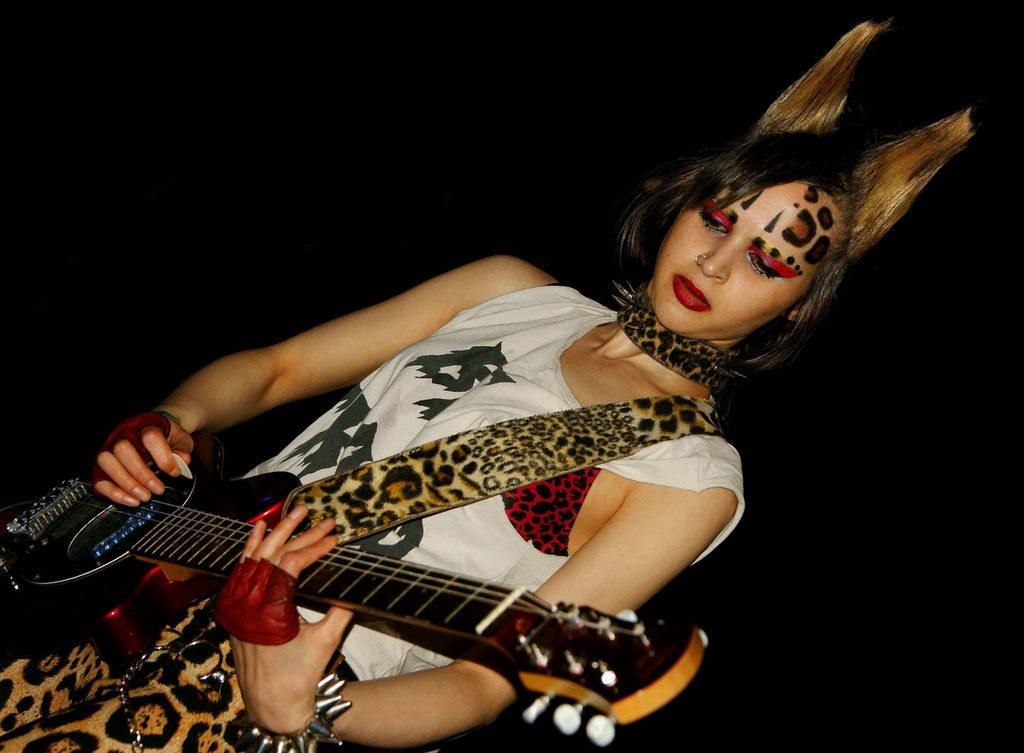Who is present in the image? There is a woman in the image. What is the woman holding in the image? The woman is holding a guitar. What type of maid is visible in the image? There is no maid present in the image; it features a woman holding a guitar. What kind of bat can be seen flying in the image? There is no bat present in the image. 